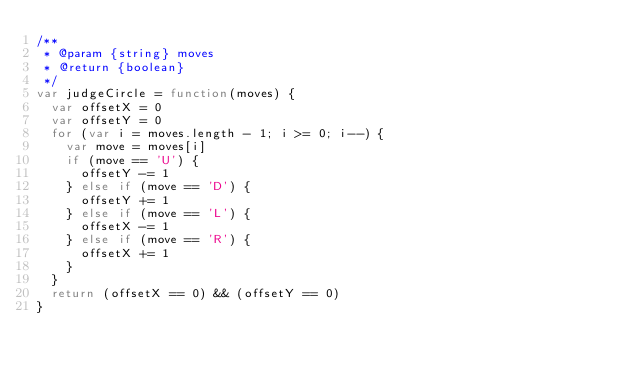Convert code to text. <code><loc_0><loc_0><loc_500><loc_500><_JavaScript_>/**
 * @param {string} moves
 * @return {boolean}
 */
var judgeCircle = function(moves) {
	var offsetX = 0
	var offsetY = 0
	for (var i = moves.length - 1; i >= 0; i--) {
		var move = moves[i]
		if (move == 'U') {
			offsetY -= 1
		} else if (move == 'D') {
			offsetY += 1
		} else if (move == 'L') {
			offsetX -= 1
		} else if (move == 'R') {
			offsetX += 1
		}
	}
	return (offsetX == 0) && (offsetY == 0)
}
</code> 